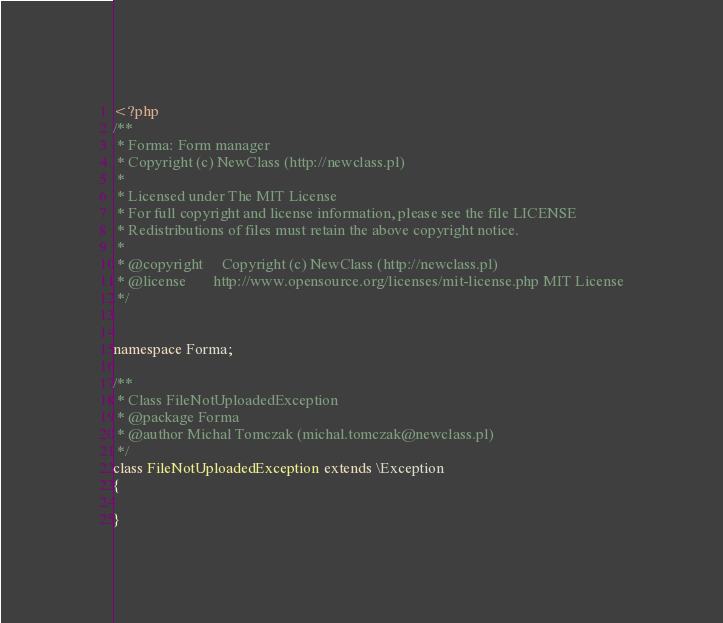Convert code to text. <code><loc_0><loc_0><loc_500><loc_500><_PHP_><?php
/**
 * Forma: Form manager
 * Copyright (c) NewClass (http://newclass.pl)
 *
 * Licensed under The MIT License
 * For full copyright and license information, please see the file LICENSE
 * Redistributions of files must retain the above copyright notice.
 *
 * @copyright     Copyright (c) NewClass (http://newclass.pl)
 * @license       http://www.opensource.org/licenses/mit-license.php MIT License
 */


namespace Forma;

/**
 * Class FileNotUploadedException
 * @package Forma
 * @author Michal Tomczak (michal.tomczak@newclass.pl)
 */
class FileNotUploadedException extends \Exception
{

}</code> 